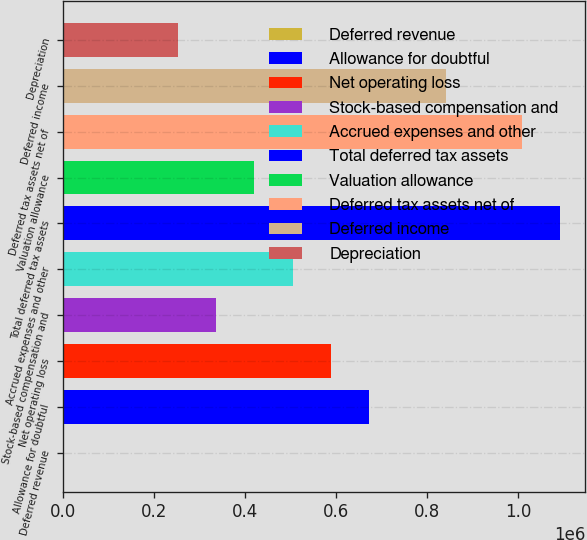<chart> <loc_0><loc_0><loc_500><loc_500><bar_chart><fcel>Deferred revenue<fcel>Allowance for doubtful<fcel>Net operating loss<fcel>Stock-based compensation and<fcel>Accrued expenses and other<fcel>Total deferred tax assets<fcel>Valuation allowance<fcel>Deferred tax assets net of<fcel>Deferred income<fcel>Depreciation<nl><fcel>200<fcel>672110<fcel>588122<fcel>336155<fcel>504133<fcel>1.09205e+06<fcel>420144<fcel>1.00807e+06<fcel>840088<fcel>252166<nl></chart> 